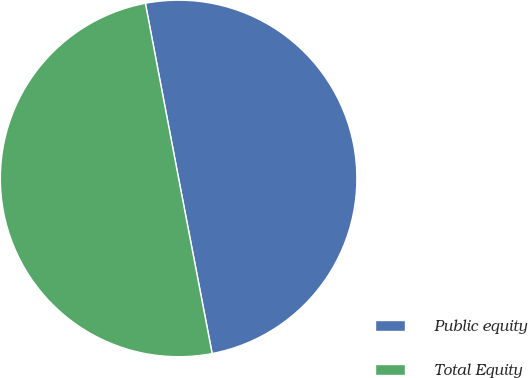Convert chart to OTSL. <chart><loc_0><loc_0><loc_500><loc_500><pie_chart><fcel>Public equity<fcel>Total Equity<nl><fcel>49.97%<fcel>50.03%<nl></chart> 